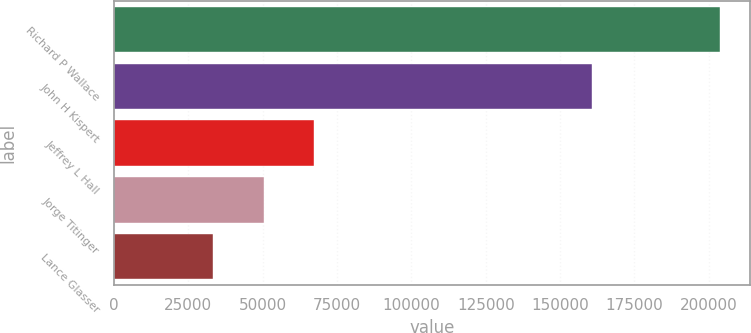Convert chart to OTSL. <chart><loc_0><loc_0><loc_500><loc_500><bar_chart><fcel>Richard P Wallace<fcel>John H Kispert<fcel>Jeffrey L Hall<fcel>Jorge Titinger<fcel>Lance Glasser<nl><fcel>203611<fcel>160833<fcel>67388.6<fcel>50360.8<fcel>33333<nl></chart> 